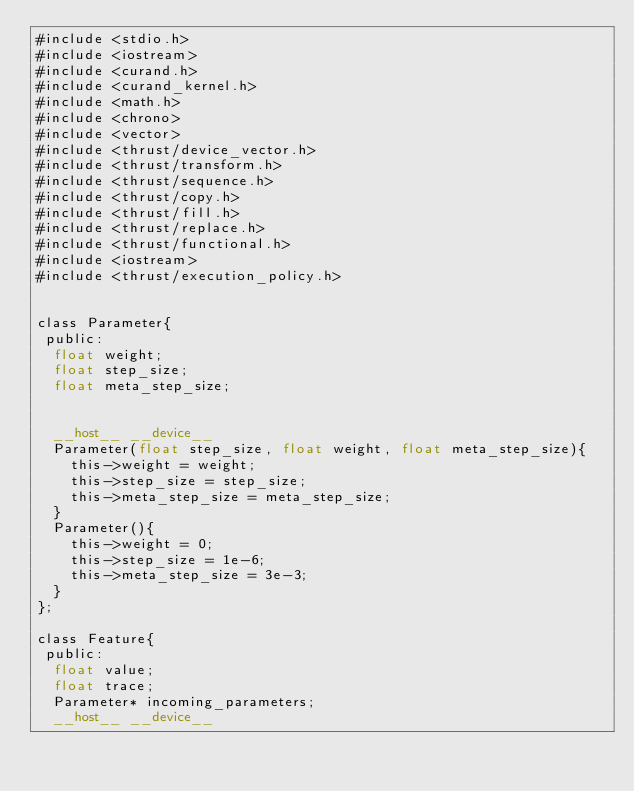<code> <loc_0><loc_0><loc_500><loc_500><_Cuda_>#include <stdio.h>
#include <iostream>
#include <curand.h>
#include <curand_kernel.h>
#include <math.h>
#include <chrono>
#include <vector>
#include <thrust/device_vector.h>
#include <thrust/transform.h>
#include <thrust/sequence.h>
#include <thrust/copy.h>
#include <thrust/fill.h>
#include <thrust/replace.h>
#include <thrust/functional.h>
#include <iostream>
#include <thrust/execution_policy.h>


class Parameter{
 public:
  float weight;
  float step_size;
  float meta_step_size;


  __host__ __device__
  Parameter(float step_size, float weight, float meta_step_size){
    this->weight = weight;
    this->step_size = step_size;
    this->meta_step_size = meta_step_size;
  }
  Parameter(){
    this->weight = 0;
    this->step_size = 1e-6;
    this->meta_step_size = 3e-3;
  }
};

class Feature{
 public:
  float value;
  float trace;
  Parameter* incoming_parameters;
  __host__ __device__</code> 